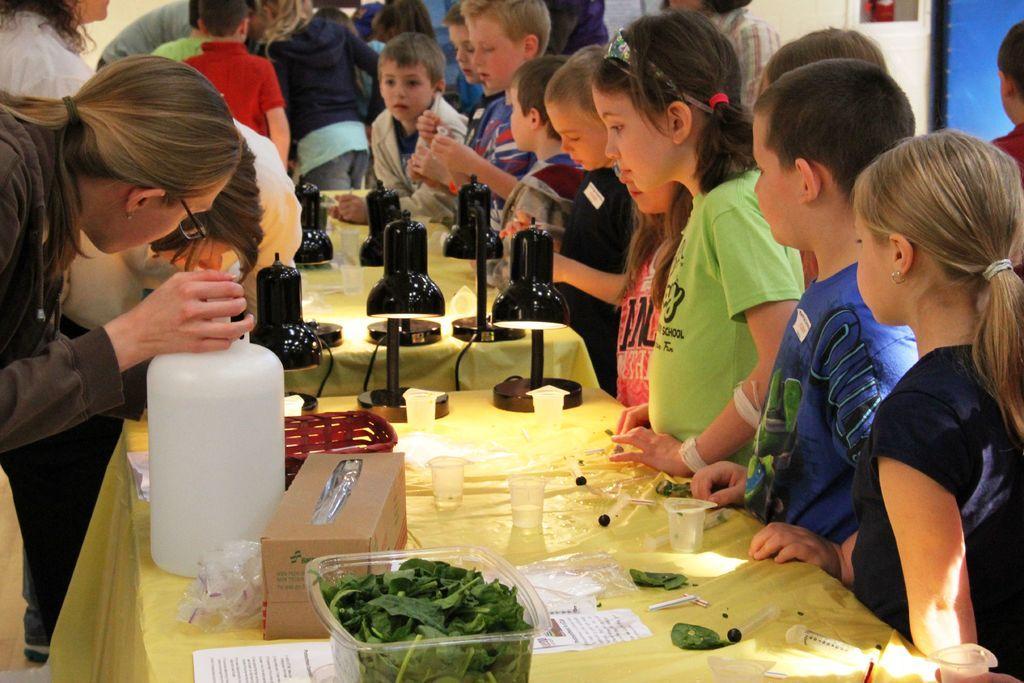How would you summarize this image in a sentence or two? In this image there are some people who are standing, and also there are some children. In the center there are some tables, on the tables there are some boxes, bowls, glasses, papers, cans and some other objects and also there are some lights. In the background there is a wall. 